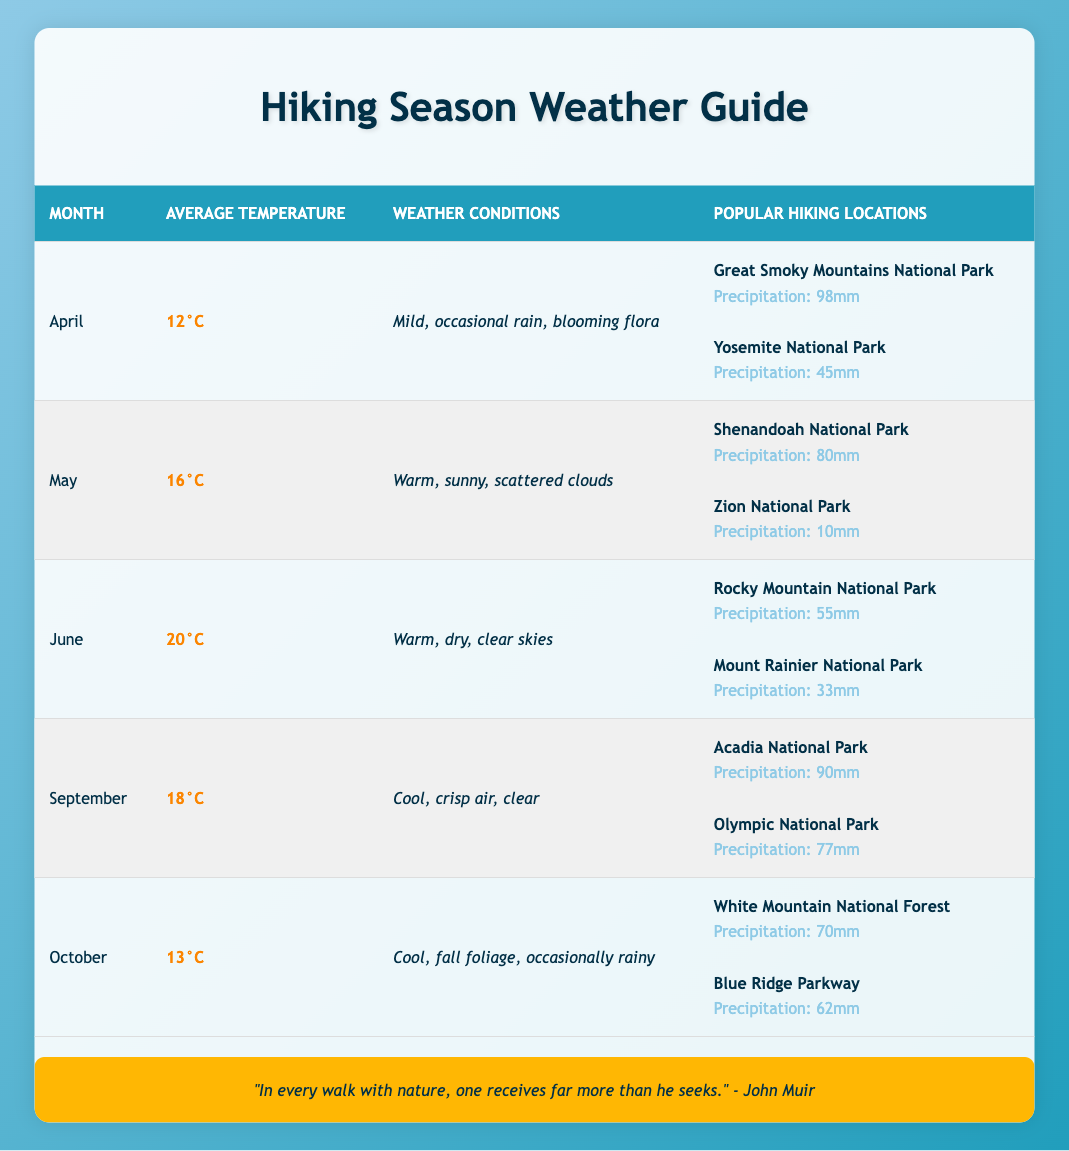What is the average temperature in June? The table shows that the average temperature for June is listed as 20°C.
Answer: 20°C How much average precipitation does Shenandoah National Park receive in May? In the May row, the table indicates that Shenandoah National Park receives an average precipitation of 80mm.
Answer: 80mm Is October characterized by warm weather conditions? The table describes October as having cool weather conditions, so it is not characterized by warm weather.
Answer: No Which month has the highest average temperature? Comparing the average temperatures across the months, June has the highest temperature at 20°C, while the others are lower.
Answer: June What is the total average precipitation for popular hiking locations in April? For April, the average precipitation for Great Smoky Mountains National Park is 98mm and for Yosemite National Park is 45mm. The total is 98mm + 45mm = 143mm.
Answer: 143mm In which month do the weather conditions describe "blooming flora"? The table states that "blooming flora" is mentioned in the weather conditions for April.
Answer: April How does the average temperature in September compare to that in May? The average temperature in September is 18°C, while in May it is 16°C. September is warmer than May by 2°C.
Answer: September is warmer by 2°C Which hiking location has the least average precipitation in the table? By examining the average precipitation for all locations, Zion National Park in May stands out with only 10mm, making it the least.
Answer: Zion National Park Is the weather in June typically described as dry? The table indicates that the weather conditions for June are listed as "warm, dry, clear skies," confirming that it is typically dry.
Answer: Yes What are the weather conditions for hiking in October? The table describes the weather conditions in October as "cool, fall foliage, occasionally rainy."
Answer: Cool, fall foliage, occasionally rainy 